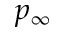Convert formula to latex. <formula><loc_0><loc_0><loc_500><loc_500>p _ { \infty }</formula> 